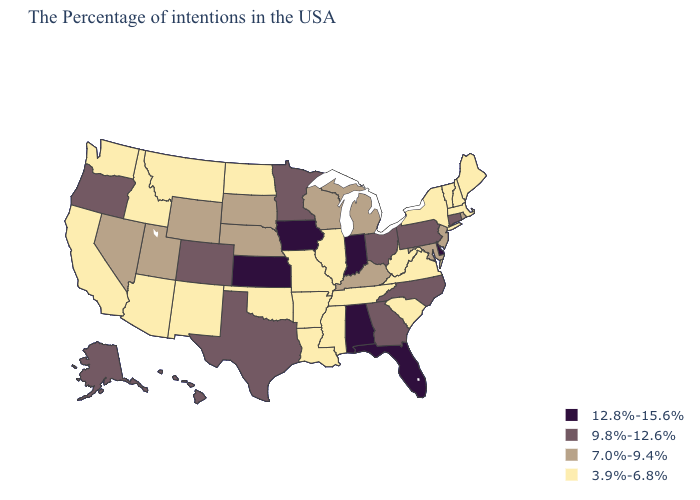What is the highest value in states that border Minnesota?
Quick response, please. 12.8%-15.6%. What is the value of New York?
Be succinct. 3.9%-6.8%. Does South Carolina have the same value as Connecticut?
Keep it brief. No. Does Georgia have a lower value than Virginia?
Quick response, please. No. What is the value of Nebraska?
Write a very short answer. 7.0%-9.4%. Among the states that border Georgia , which have the lowest value?
Be succinct. South Carolina, Tennessee. What is the highest value in the Northeast ?
Write a very short answer. 9.8%-12.6%. What is the value of Utah?
Be succinct. 7.0%-9.4%. Which states have the highest value in the USA?
Short answer required. Delaware, Florida, Indiana, Alabama, Iowa, Kansas. How many symbols are there in the legend?
Answer briefly. 4. Does Washington have a higher value than Mississippi?
Concise answer only. No. Does Iowa have the highest value in the MidWest?
Be succinct. Yes. Does Maryland have the lowest value in the USA?
Answer briefly. No. Does Utah have the lowest value in the West?
Answer briefly. No. Does the first symbol in the legend represent the smallest category?
Give a very brief answer. No. 